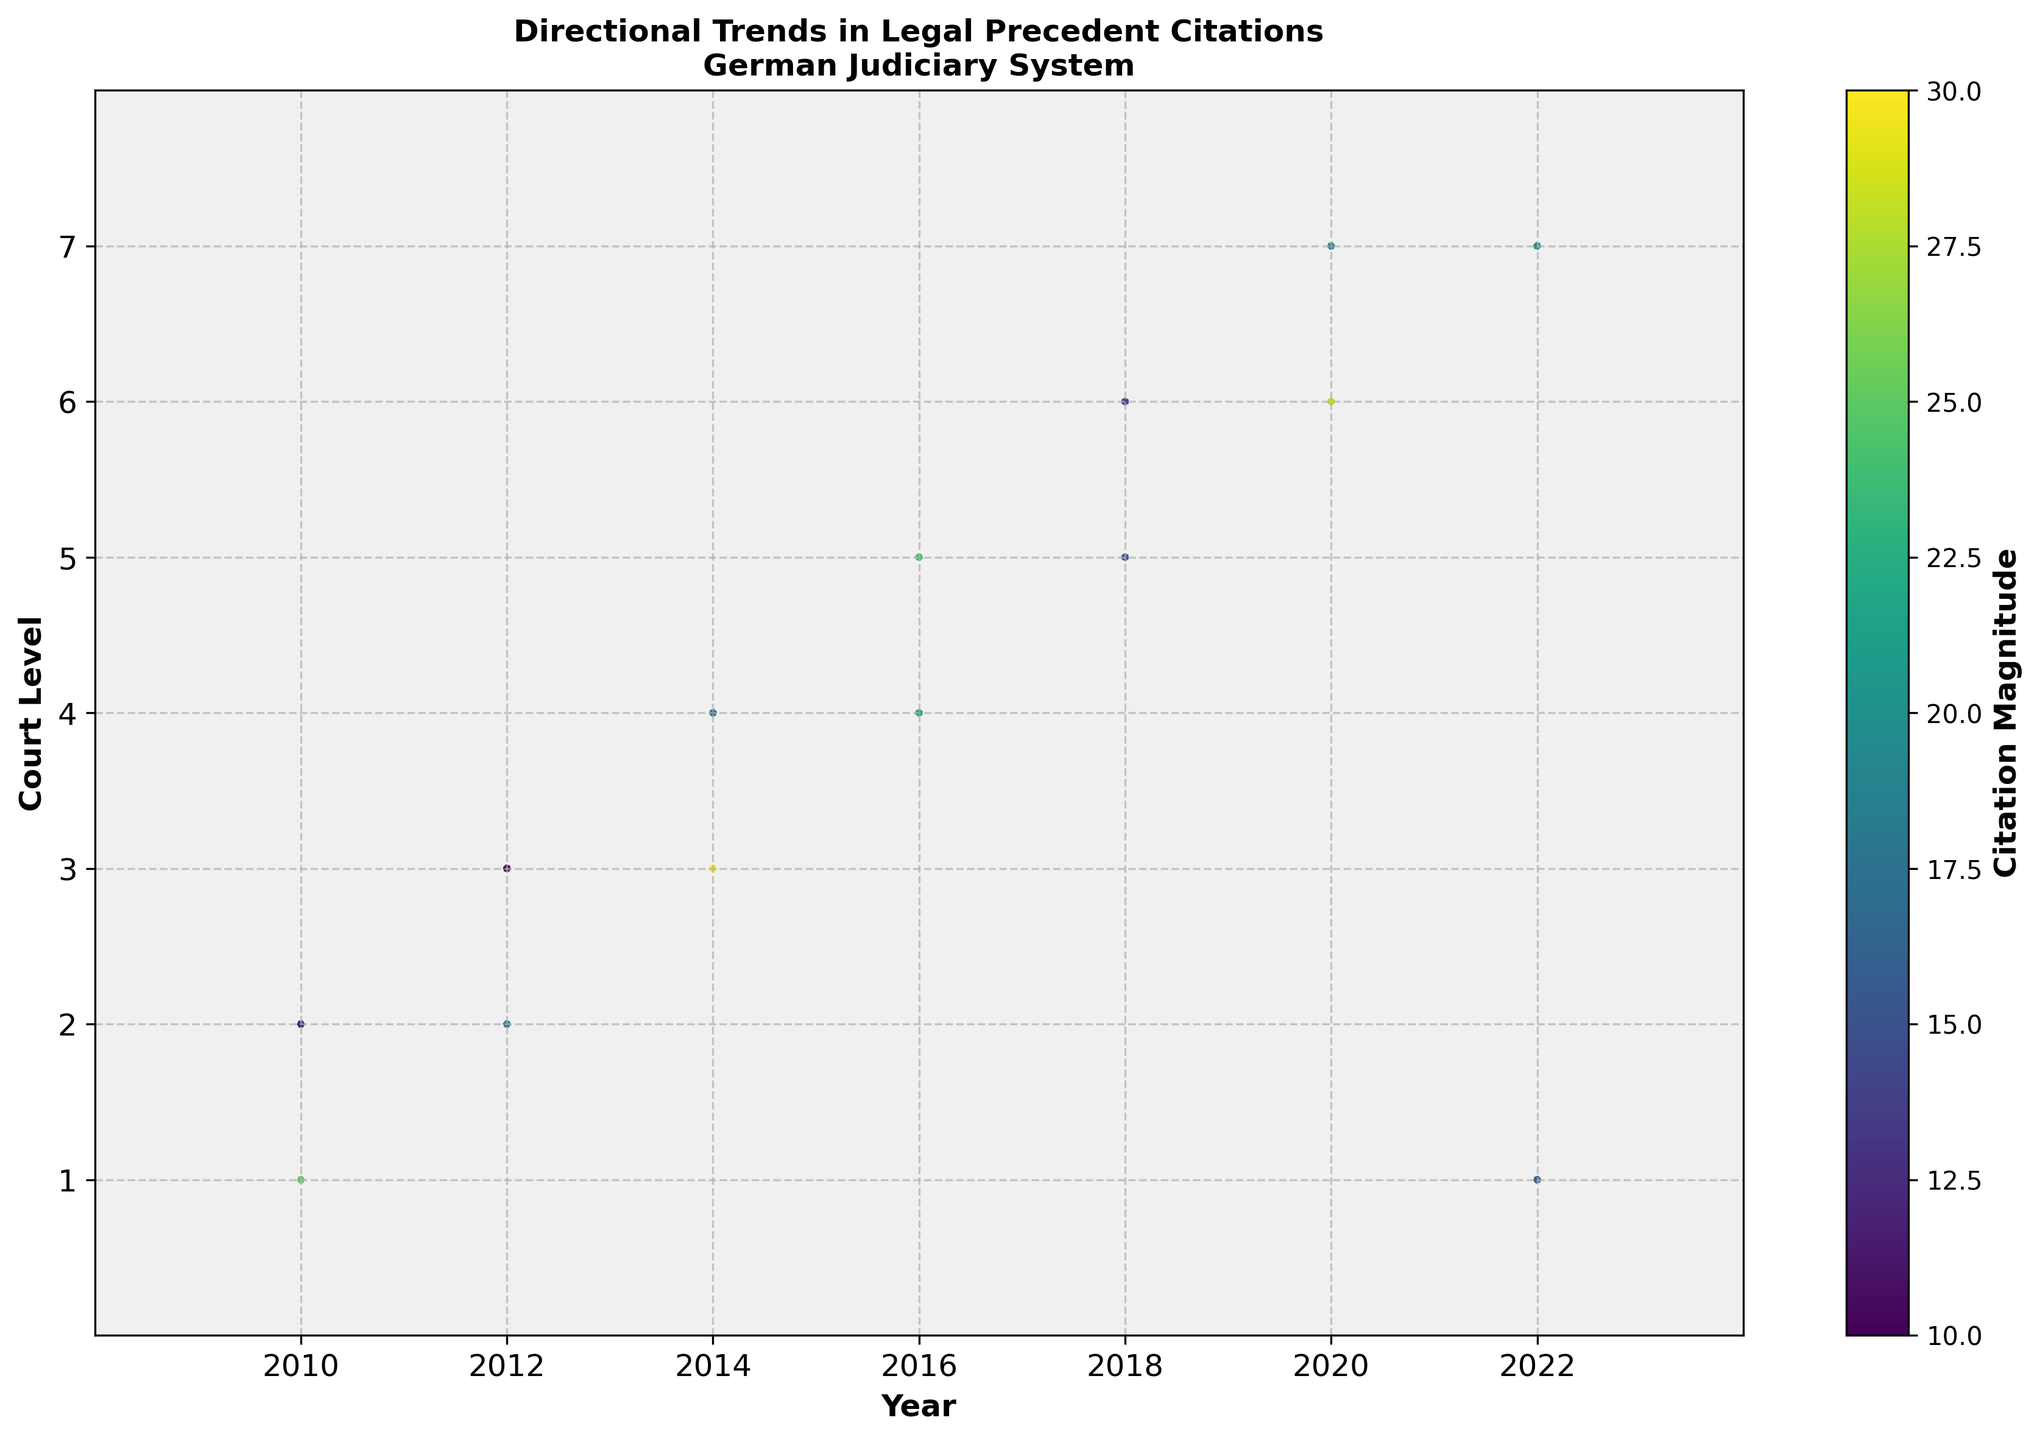What is the title of the figure? The title of the figure is displayed at the top. By reading the text, we can see the title is "Directional Trends in Legal Precedent Citations\nGerman Judiciary System"
Answer: Directional Trends in Legal Precedent Citations\nGerman Judiciary System How many levels of courts are represented in the figure? The y-axis is labeled "Court Level" and ranges from 1 to 7, with tick marks at these values. This indicates that there are 7 levels of courts represented.
Answer: 7 In which year does the data point at the highest court level show a significant upward trend? The highest court level corresponds to y=7. The arrow for the year 2022 at this court level points strongly upwards, indicating a significant upward trend.
Answer: 2022 Which data point has the highest citation magnitude, and what year does it correspond to? To identify this, we refer to the color bar and matching data points. The most intensive color represents the highest magnitude, which appears to be the point (2014, 3). From the data, the value is 30 in the year 2014.
Answer: 2014 What is the direction and magnitude of the trend for the data point at court level 1 in 2022? At court level 1 in 2022 (bottom-left), the arrow points leftwards, and downwards and is colored somewhat moderately. Referring to the data shows ‘u=-0.2’, ‘v=-0.5’, and ‘magnitude=16’.
Answer: Leftwards and downwards, magnitude 16 Which year has the most citations with an upward trend at court level 5? At court level 5, locate the arrows pointing upwards by their direction ('v' component). From the data, only the arrow at 2014 points upwards with 'u=0.2’ and 'v=0.5’.
Answer: 2014 Compare the citation trends between years 2016 and 2020 at court level 6. Which one shows a stronger upward trend? Court level 6 for 2016 and 2020 needs comparison based on the ‘v’ component and magnitude. In 2020, the arrow points upwards significantly (‘v=0.6’), compared to the modest upward trend in 2016 (‘v=0.2’).
Answer: 2020 What can be inferred about the overall trend in citations at court level 2 from 2010 to 2018? By examining the arrows corresponding to court level 2, the data points follow various directions from 2010 to 2018. In 2010, the trend is upward ('u=0.4', 'v=-0.4'). In 2012, the trend shows a rightward and upward direction ('u=-0.2', 'v=0.4'). The mixed directions suggest no consistent trend in citations at this court level.
Answer: Mixed trends Which court level saw a significant reduction in citations in the year 2018? To find the court level with reduced citations, we need to find arrows pointing significantly leftwards or downwards at year 2018. Court level 5 (2018, 5) shows 'u=-0.4', 'v=-0.2’ indicating a reduction.
Answer: Court level 5 